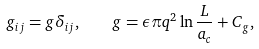Convert formula to latex. <formula><loc_0><loc_0><loc_500><loc_500>g _ { i j } = g \delta _ { i j } , \quad g = \epsilon \pi q ^ { 2 } \ln \frac { L } { a _ { c } } + C _ { g } ,</formula> 